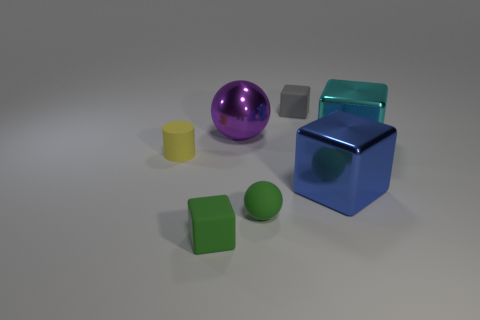Subtract all cyan cubes. How many cubes are left? 3 Subtract 3 blocks. How many blocks are left? 1 Add 3 gray things. How many objects exist? 10 Subtract all green spheres. How many spheres are left? 1 Subtract all cylinders. How many objects are left? 6 Subtract all cyan cylinders. How many red cubes are left? 0 Add 5 big cyan metal objects. How many big cyan metal objects are left? 6 Add 2 green matte objects. How many green matte objects exist? 4 Subtract 0 brown balls. How many objects are left? 7 Subtract all brown cylinders. Subtract all blue balls. How many cylinders are left? 1 